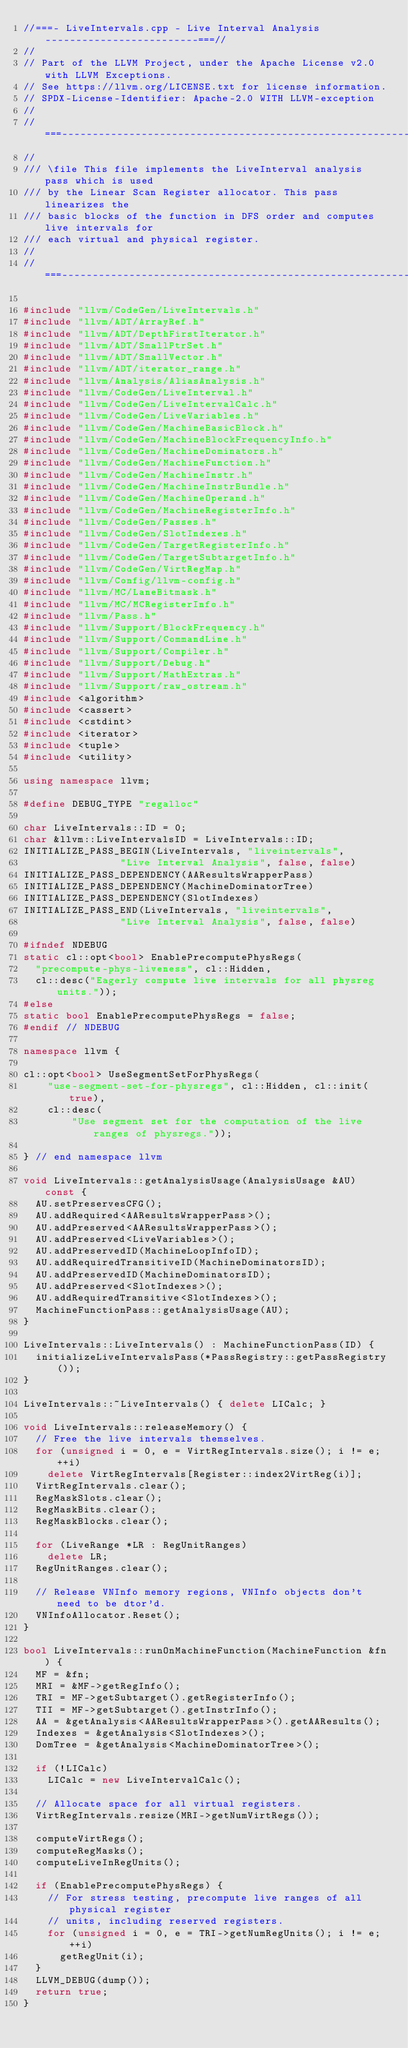Convert code to text. <code><loc_0><loc_0><loc_500><loc_500><_C++_>//===- LiveIntervals.cpp - Live Interval Analysis -------------------------===//
//
// Part of the LLVM Project, under the Apache License v2.0 with LLVM Exceptions.
// See https://llvm.org/LICENSE.txt for license information.
// SPDX-License-Identifier: Apache-2.0 WITH LLVM-exception
//
//===----------------------------------------------------------------------===//
//
/// \file This file implements the LiveInterval analysis pass which is used
/// by the Linear Scan Register allocator. This pass linearizes the
/// basic blocks of the function in DFS order and computes live intervals for
/// each virtual and physical register.
//
//===----------------------------------------------------------------------===//

#include "llvm/CodeGen/LiveIntervals.h"
#include "llvm/ADT/ArrayRef.h"
#include "llvm/ADT/DepthFirstIterator.h"
#include "llvm/ADT/SmallPtrSet.h"
#include "llvm/ADT/SmallVector.h"
#include "llvm/ADT/iterator_range.h"
#include "llvm/Analysis/AliasAnalysis.h"
#include "llvm/CodeGen/LiveInterval.h"
#include "llvm/CodeGen/LiveIntervalCalc.h"
#include "llvm/CodeGen/LiveVariables.h"
#include "llvm/CodeGen/MachineBasicBlock.h"
#include "llvm/CodeGen/MachineBlockFrequencyInfo.h"
#include "llvm/CodeGen/MachineDominators.h"
#include "llvm/CodeGen/MachineFunction.h"
#include "llvm/CodeGen/MachineInstr.h"
#include "llvm/CodeGen/MachineInstrBundle.h"
#include "llvm/CodeGen/MachineOperand.h"
#include "llvm/CodeGen/MachineRegisterInfo.h"
#include "llvm/CodeGen/Passes.h"
#include "llvm/CodeGen/SlotIndexes.h"
#include "llvm/CodeGen/TargetRegisterInfo.h"
#include "llvm/CodeGen/TargetSubtargetInfo.h"
#include "llvm/CodeGen/VirtRegMap.h"
#include "llvm/Config/llvm-config.h"
#include "llvm/MC/LaneBitmask.h"
#include "llvm/MC/MCRegisterInfo.h"
#include "llvm/Pass.h"
#include "llvm/Support/BlockFrequency.h"
#include "llvm/Support/CommandLine.h"
#include "llvm/Support/Compiler.h"
#include "llvm/Support/Debug.h"
#include "llvm/Support/MathExtras.h"
#include "llvm/Support/raw_ostream.h"
#include <algorithm>
#include <cassert>
#include <cstdint>
#include <iterator>
#include <tuple>
#include <utility>

using namespace llvm;

#define DEBUG_TYPE "regalloc"

char LiveIntervals::ID = 0;
char &llvm::LiveIntervalsID = LiveIntervals::ID;
INITIALIZE_PASS_BEGIN(LiveIntervals, "liveintervals",
                "Live Interval Analysis", false, false)
INITIALIZE_PASS_DEPENDENCY(AAResultsWrapperPass)
INITIALIZE_PASS_DEPENDENCY(MachineDominatorTree)
INITIALIZE_PASS_DEPENDENCY(SlotIndexes)
INITIALIZE_PASS_END(LiveIntervals, "liveintervals",
                "Live Interval Analysis", false, false)

#ifndef NDEBUG
static cl::opt<bool> EnablePrecomputePhysRegs(
  "precompute-phys-liveness", cl::Hidden,
  cl::desc("Eagerly compute live intervals for all physreg units."));
#else
static bool EnablePrecomputePhysRegs = false;
#endif // NDEBUG

namespace llvm {

cl::opt<bool> UseSegmentSetForPhysRegs(
    "use-segment-set-for-physregs", cl::Hidden, cl::init(true),
    cl::desc(
        "Use segment set for the computation of the live ranges of physregs."));

} // end namespace llvm

void LiveIntervals::getAnalysisUsage(AnalysisUsage &AU) const {
  AU.setPreservesCFG();
  AU.addRequired<AAResultsWrapperPass>();
  AU.addPreserved<AAResultsWrapperPass>();
  AU.addPreserved<LiveVariables>();
  AU.addPreservedID(MachineLoopInfoID);
  AU.addRequiredTransitiveID(MachineDominatorsID);
  AU.addPreservedID(MachineDominatorsID);
  AU.addPreserved<SlotIndexes>();
  AU.addRequiredTransitive<SlotIndexes>();
  MachineFunctionPass::getAnalysisUsage(AU);
}

LiveIntervals::LiveIntervals() : MachineFunctionPass(ID) {
  initializeLiveIntervalsPass(*PassRegistry::getPassRegistry());
}

LiveIntervals::~LiveIntervals() { delete LICalc; }

void LiveIntervals::releaseMemory() {
  // Free the live intervals themselves.
  for (unsigned i = 0, e = VirtRegIntervals.size(); i != e; ++i)
    delete VirtRegIntervals[Register::index2VirtReg(i)];
  VirtRegIntervals.clear();
  RegMaskSlots.clear();
  RegMaskBits.clear();
  RegMaskBlocks.clear();

  for (LiveRange *LR : RegUnitRanges)
    delete LR;
  RegUnitRanges.clear();

  // Release VNInfo memory regions, VNInfo objects don't need to be dtor'd.
  VNInfoAllocator.Reset();
}

bool LiveIntervals::runOnMachineFunction(MachineFunction &fn) {
  MF = &fn;
  MRI = &MF->getRegInfo();
  TRI = MF->getSubtarget().getRegisterInfo();
  TII = MF->getSubtarget().getInstrInfo();
  AA = &getAnalysis<AAResultsWrapperPass>().getAAResults();
  Indexes = &getAnalysis<SlotIndexes>();
  DomTree = &getAnalysis<MachineDominatorTree>();

  if (!LICalc)
    LICalc = new LiveIntervalCalc();

  // Allocate space for all virtual registers.
  VirtRegIntervals.resize(MRI->getNumVirtRegs());

  computeVirtRegs();
  computeRegMasks();
  computeLiveInRegUnits();

  if (EnablePrecomputePhysRegs) {
    // For stress testing, precompute live ranges of all physical register
    // units, including reserved registers.
    for (unsigned i = 0, e = TRI->getNumRegUnits(); i != e; ++i)
      getRegUnit(i);
  }
  LLVM_DEBUG(dump());
  return true;
}
</code> 